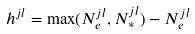<formula> <loc_0><loc_0><loc_500><loc_500>h ^ { j l } = \max ( N ^ { j l } _ { e } , N ^ { j l } _ { * } ) - N ^ { j l } _ { e }</formula> 